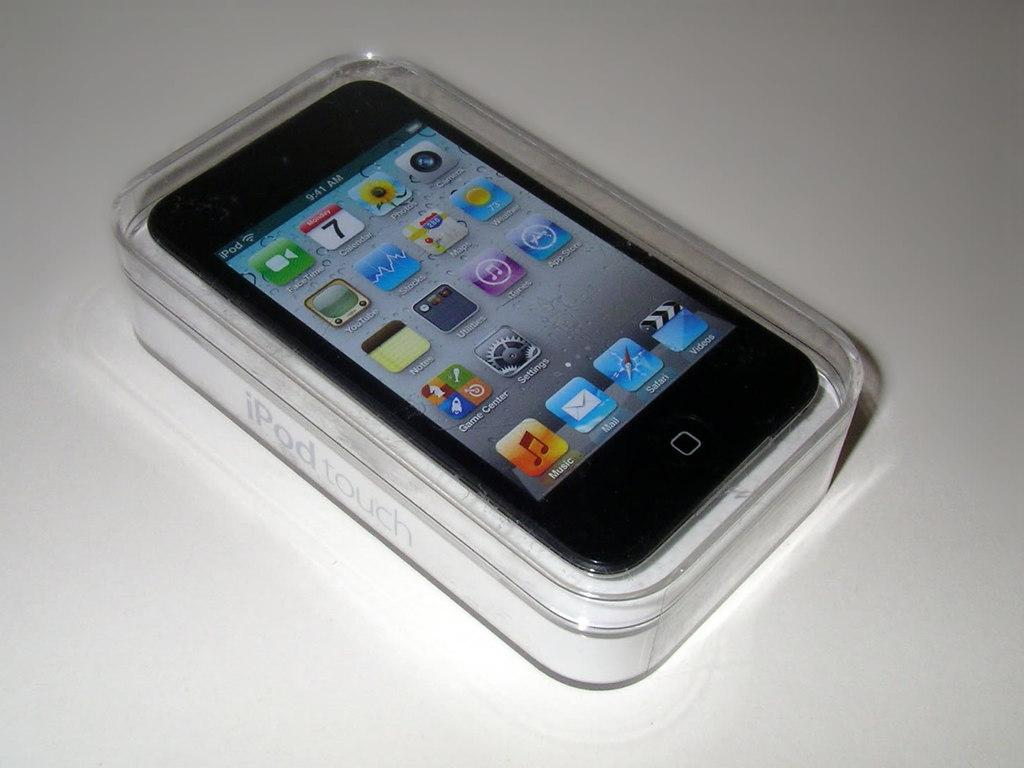What is the main object in the image? There is a mobile in the image. What is the color of the surface on which the mobile is placed? The mobile is on a white surface. What can be seen on the screen of the mobile? There are icons visible on the screen of the mobile. How many children are sitting at the dinner table in the image? There are no children or dinner table present in the image; it only features a mobile on a white surface. 